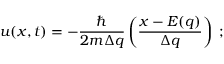<formula> <loc_0><loc_0><loc_500><loc_500>u ( x , t ) = - \frac { } { 2 m \Delta q } \left ( \frac { x - E ( q ) } { \Delta q } \right ) \, ;</formula> 